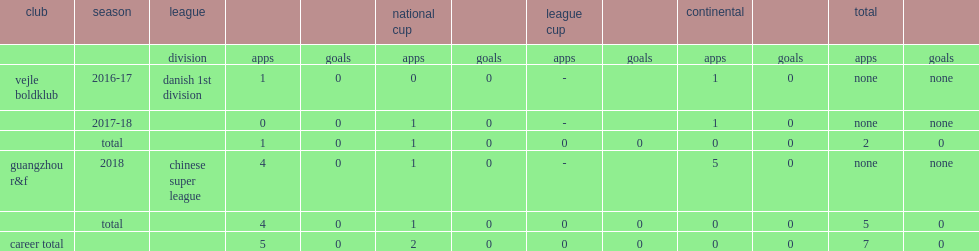Which club did wang xin play for in 2018? Guangzhou r&f. 